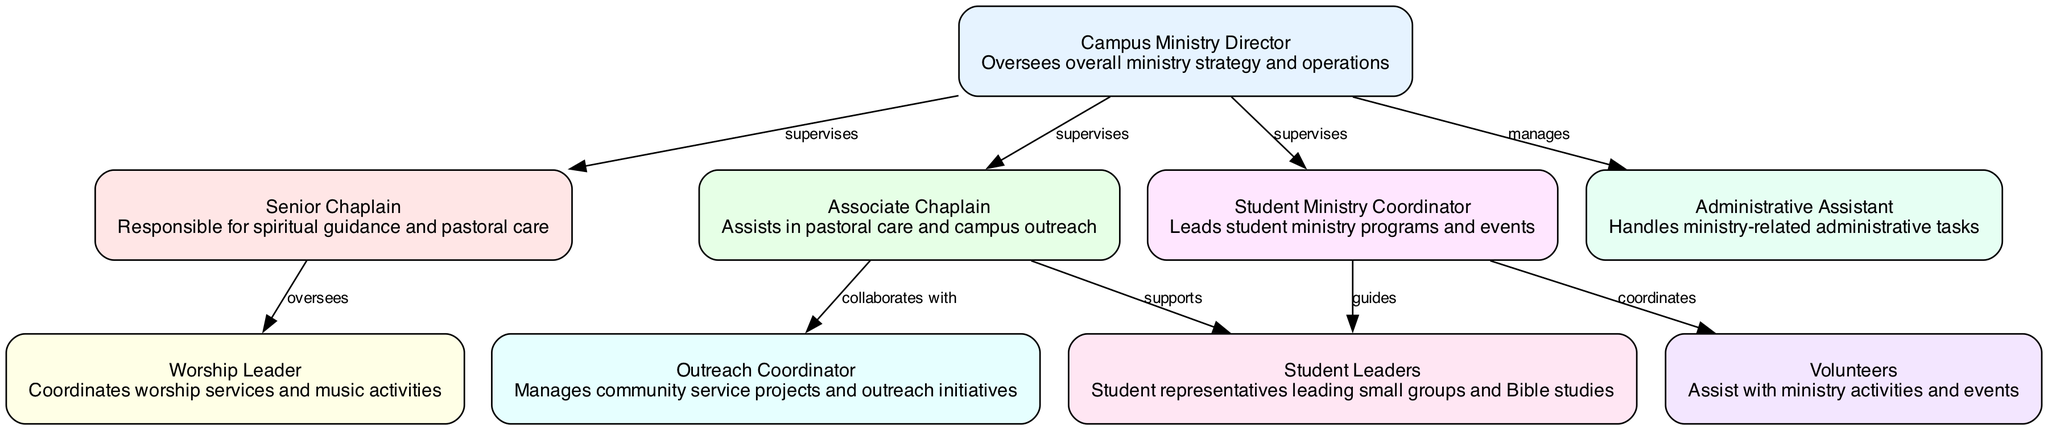What is the title of the topmost node in the diagram? The topmost node is labeled "Campus Ministry Director".
Answer: Campus Ministry Director How many nodes are in the diagram? By counting all the distinct roles listed in the nodes section, there are a total of 9 nodes.
Answer: 9 Which role supervises the Senior Chaplain? The role that supervises the Senior Chaplain is the "Campus Ministry Director".
Answer: Campus Ministry Director Who collaborates with the Associate Chaplain? The Associate Chaplain collaborates with the Outreach Coordinator.
Answer: Outreach Coordinator Which role is responsible for coordinating worship services? The role responsible for coordinating worship services is the "Worship Leader".
Answer: Worship Leader What is the relationship between the Student Ministry Coordinator and Student Leaders? The Student Ministry Coordinator guides the Student Leaders.
Answer: guides How many roles report directly to the Campus Ministry Director? The Campus Ministry Director supervises 4 roles directly, which are the Senior Chaplain, Associate Chaplain, Student Ministry Coordinator, and Administrative Assistant.
Answer: 4 What type of projects does the Outreach Coordinator manage? The Outreach Coordinator manages community service projects and outreach initiatives.
Answer: community service projects and outreach initiatives What is the function of Volunteers in the Campus Ministry? Volunteers assist with ministry activities and events, supporting various programs.
Answer: assist with ministry activities and events 